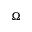Convert formula to latex. <formula><loc_0><loc_0><loc_500><loc_500>\Omega</formula> 